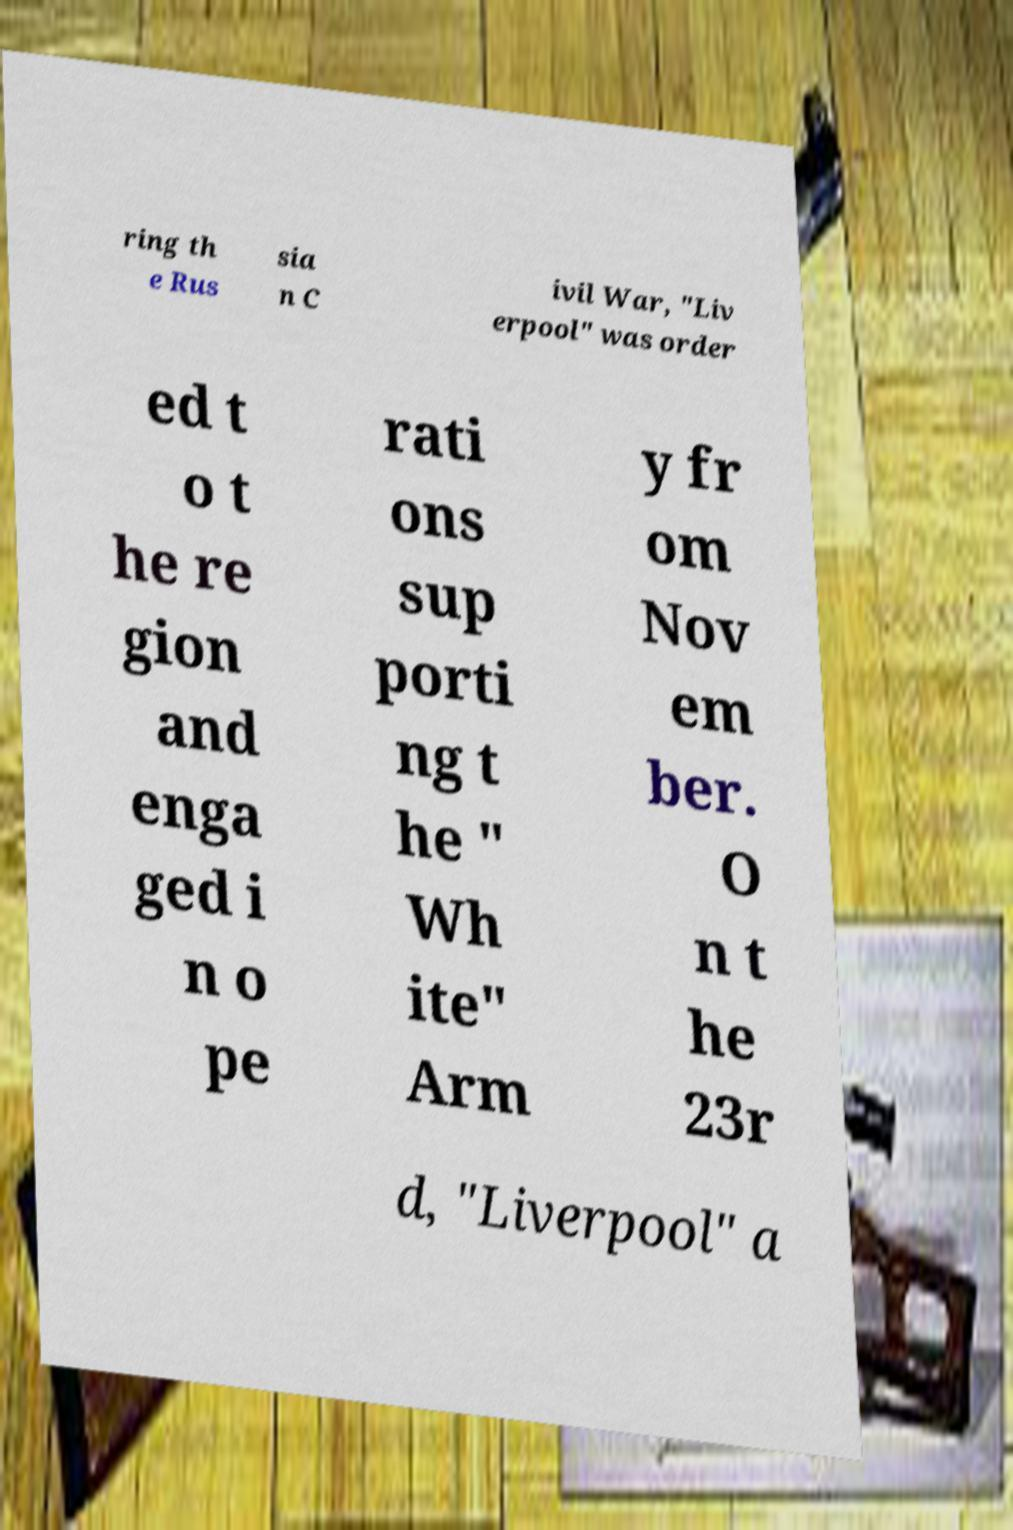Can you accurately transcribe the text from the provided image for me? ring th e Rus sia n C ivil War, "Liv erpool" was order ed t o t he re gion and enga ged i n o pe rati ons sup porti ng t he " Wh ite" Arm y fr om Nov em ber. O n t he 23r d, "Liverpool" a 